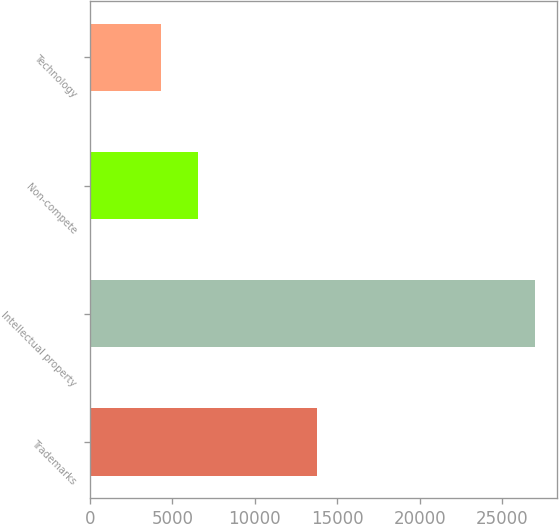Convert chart. <chart><loc_0><loc_0><loc_500><loc_500><bar_chart><fcel>Trademarks<fcel>Intellectual property<fcel>Non-compete<fcel>Technology<nl><fcel>13777<fcel>26956<fcel>6572.8<fcel>4308<nl></chart> 